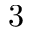Convert formula to latex. <formula><loc_0><loc_0><loc_500><loc_500>3</formula> 